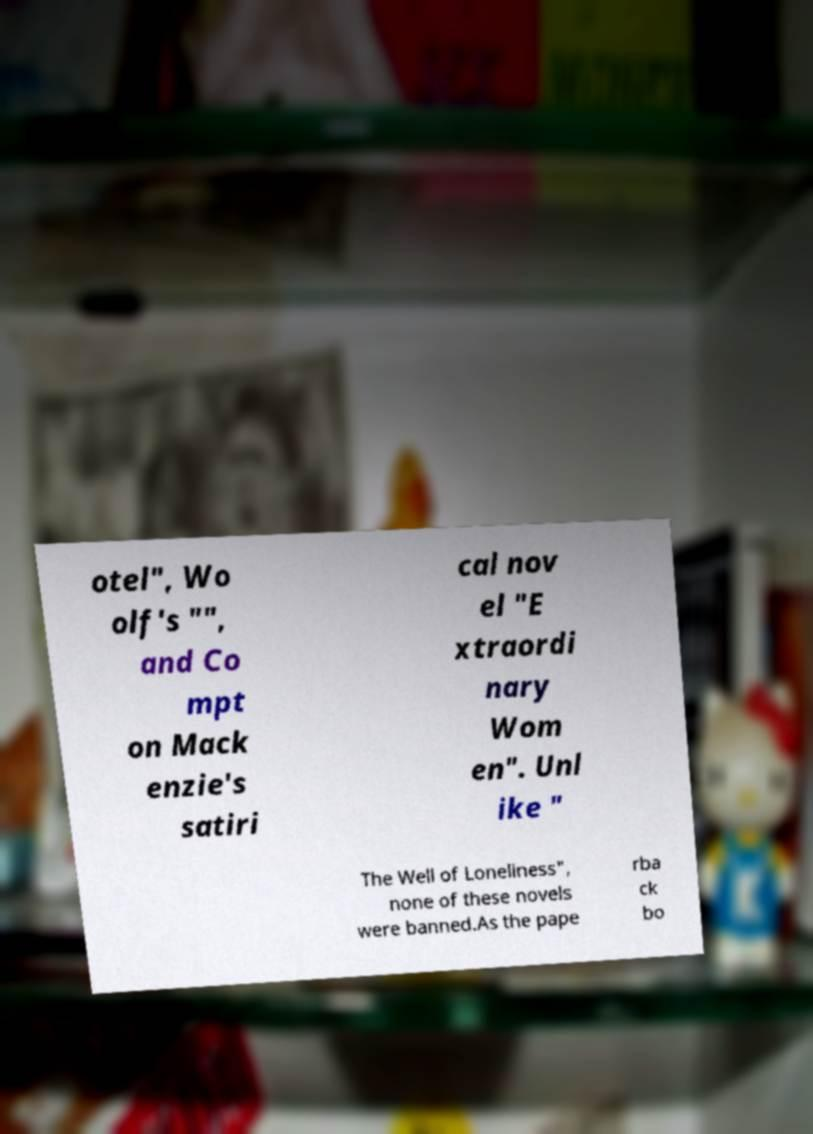Could you assist in decoding the text presented in this image and type it out clearly? otel", Wo olf's "", and Co mpt on Mack enzie's satiri cal nov el "E xtraordi nary Wom en". Unl ike " The Well of Loneliness", none of these novels were banned.As the pape rba ck bo 